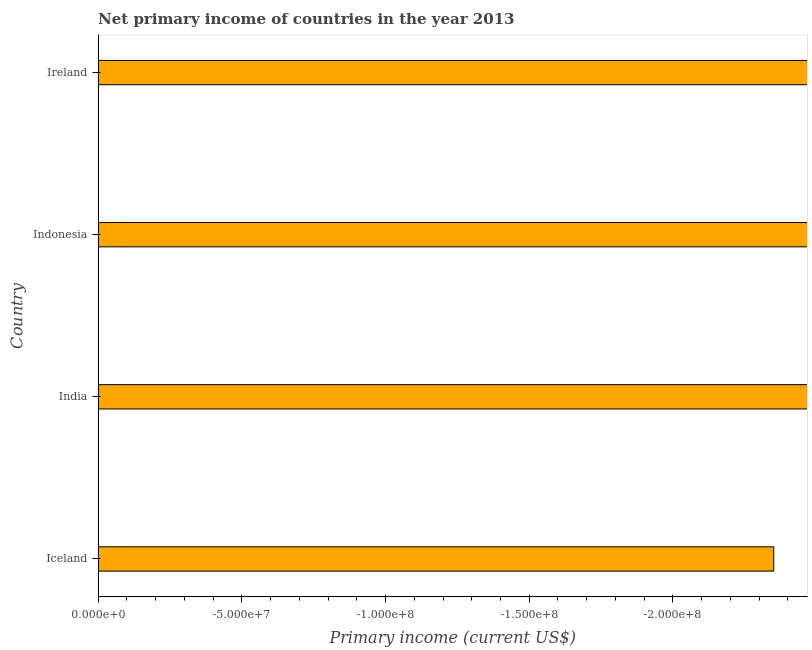What is the title of the graph?
Provide a short and direct response. Net primary income of countries in the year 2013. What is the label or title of the X-axis?
Provide a short and direct response. Primary income (current US$). What is the label or title of the Y-axis?
Keep it short and to the point. Country. Across all countries, what is the minimum amount of primary income?
Your answer should be very brief. 0. What is the average amount of primary income per country?
Make the answer very short. 0. What is the median amount of primary income?
Make the answer very short. 0. In how many countries, is the amount of primary income greater than -60000000 US$?
Provide a succinct answer. 0. How many bars are there?
Offer a very short reply. 0. How many countries are there in the graph?
Make the answer very short. 4. What is the difference between two consecutive major ticks on the X-axis?
Provide a succinct answer. 5.00e+07. What is the Primary income (current US$) of India?
Make the answer very short. 0. 